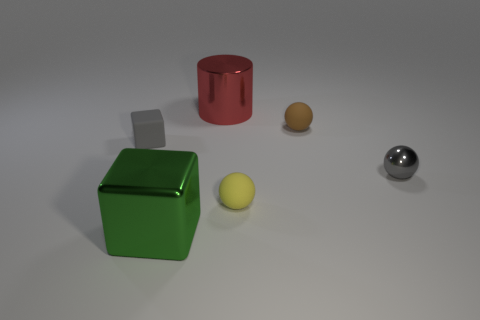Add 4 tiny brown matte objects. How many objects exist? 10 Subtract all small yellow rubber spheres. How many spheres are left? 2 Subtract all gray balls. How many balls are left? 2 Subtract 3 balls. How many balls are left? 0 Subtract all blue blocks. Subtract all blue cylinders. How many blocks are left? 2 Subtract all gray blocks. How many cyan cylinders are left? 0 Subtract all spheres. Subtract all tiny gray rubber cubes. How many objects are left? 2 Add 5 tiny metal things. How many tiny metal things are left? 6 Add 1 tiny cyan matte cylinders. How many tiny cyan matte cylinders exist? 1 Subtract 0 cyan balls. How many objects are left? 6 